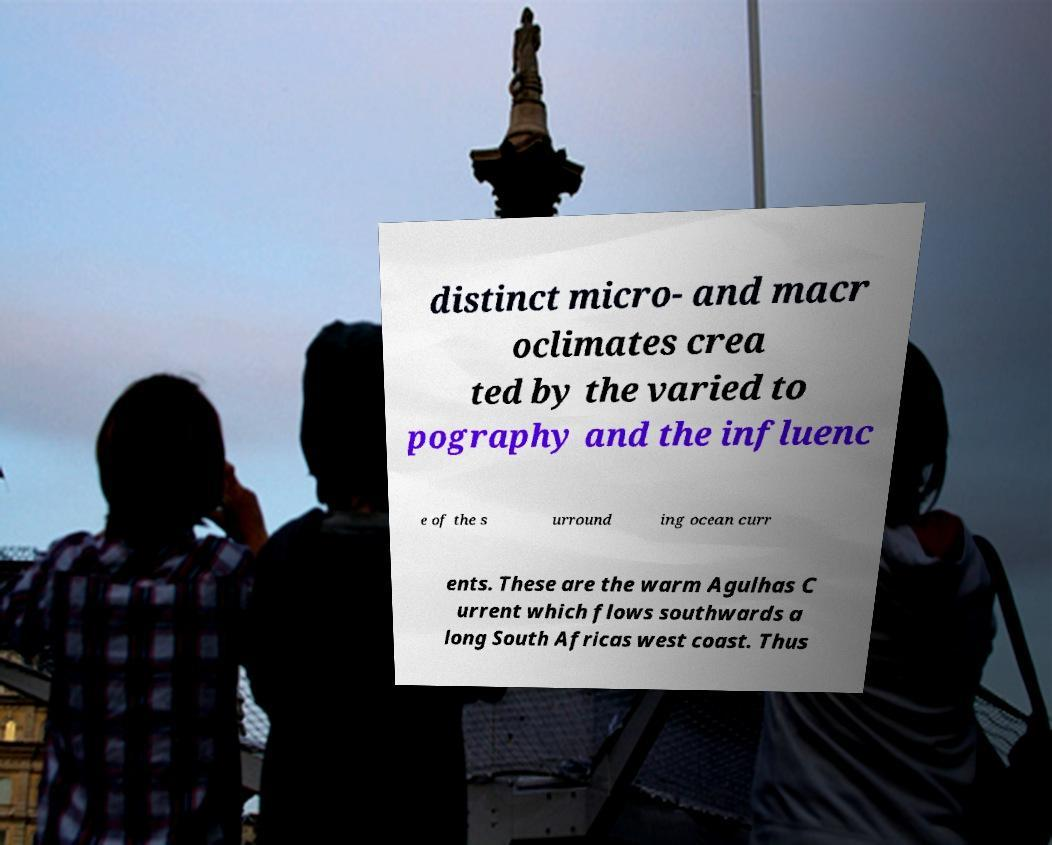Please read and relay the text visible in this image. What does it say? distinct micro- and macr oclimates crea ted by the varied to pography and the influenc e of the s urround ing ocean curr ents. These are the warm Agulhas C urrent which flows southwards a long South Africas west coast. Thus 